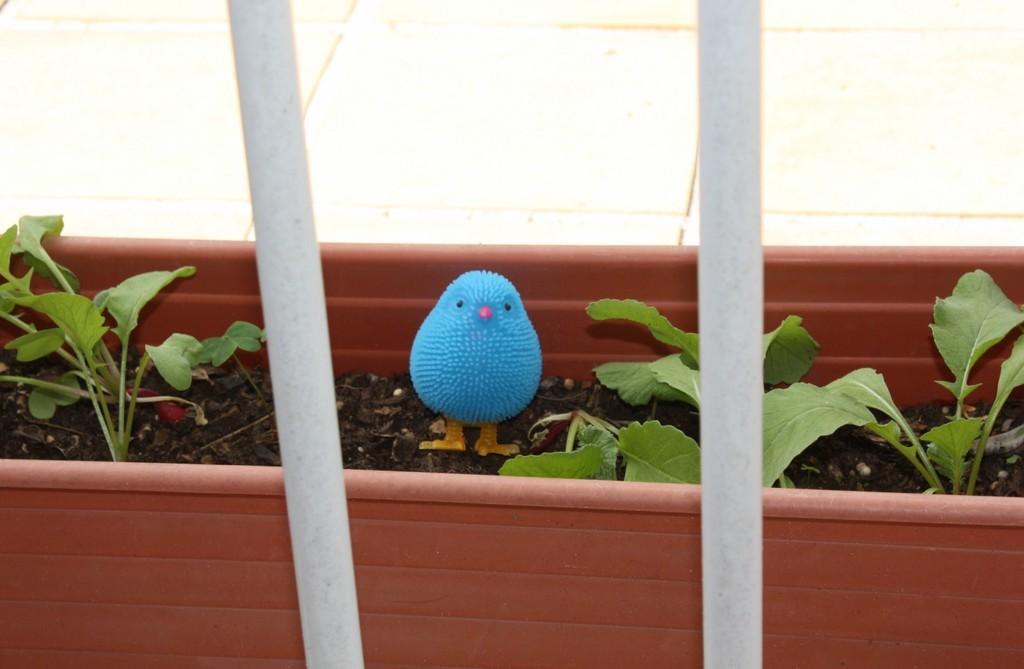Describe this image in one or two sentences. We can see toy bird on soil and we can see plants. In the background we can see wall. 